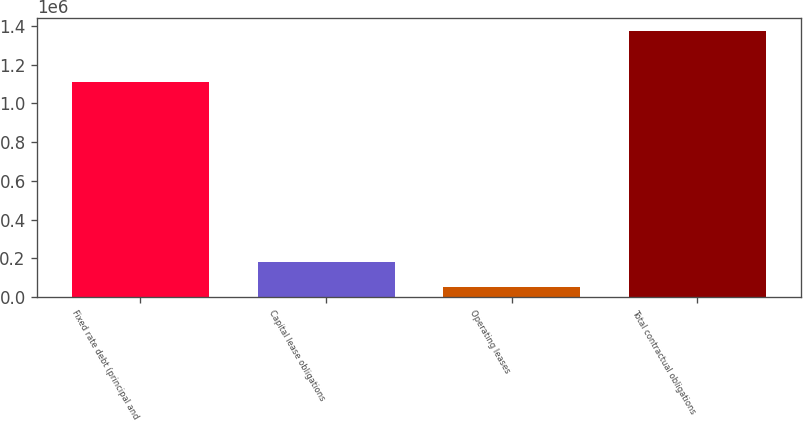<chart> <loc_0><loc_0><loc_500><loc_500><bar_chart><fcel>Fixed rate debt (principal and<fcel>Capital lease obligations<fcel>Operating leases<fcel>Total contractual obligations<nl><fcel>1.10866e+06<fcel>184080<fcel>51843<fcel>1.37421e+06<nl></chart> 